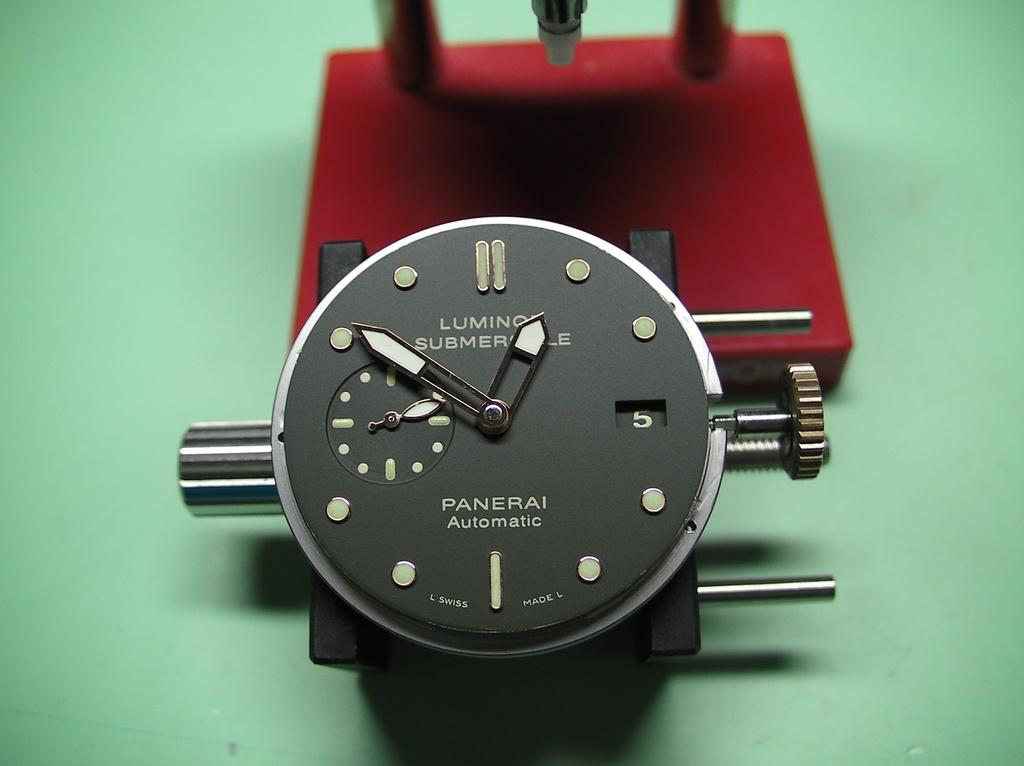<image>
Offer a succinct explanation of the picture presented. A black Panerai watches displays the time of 12:51. 